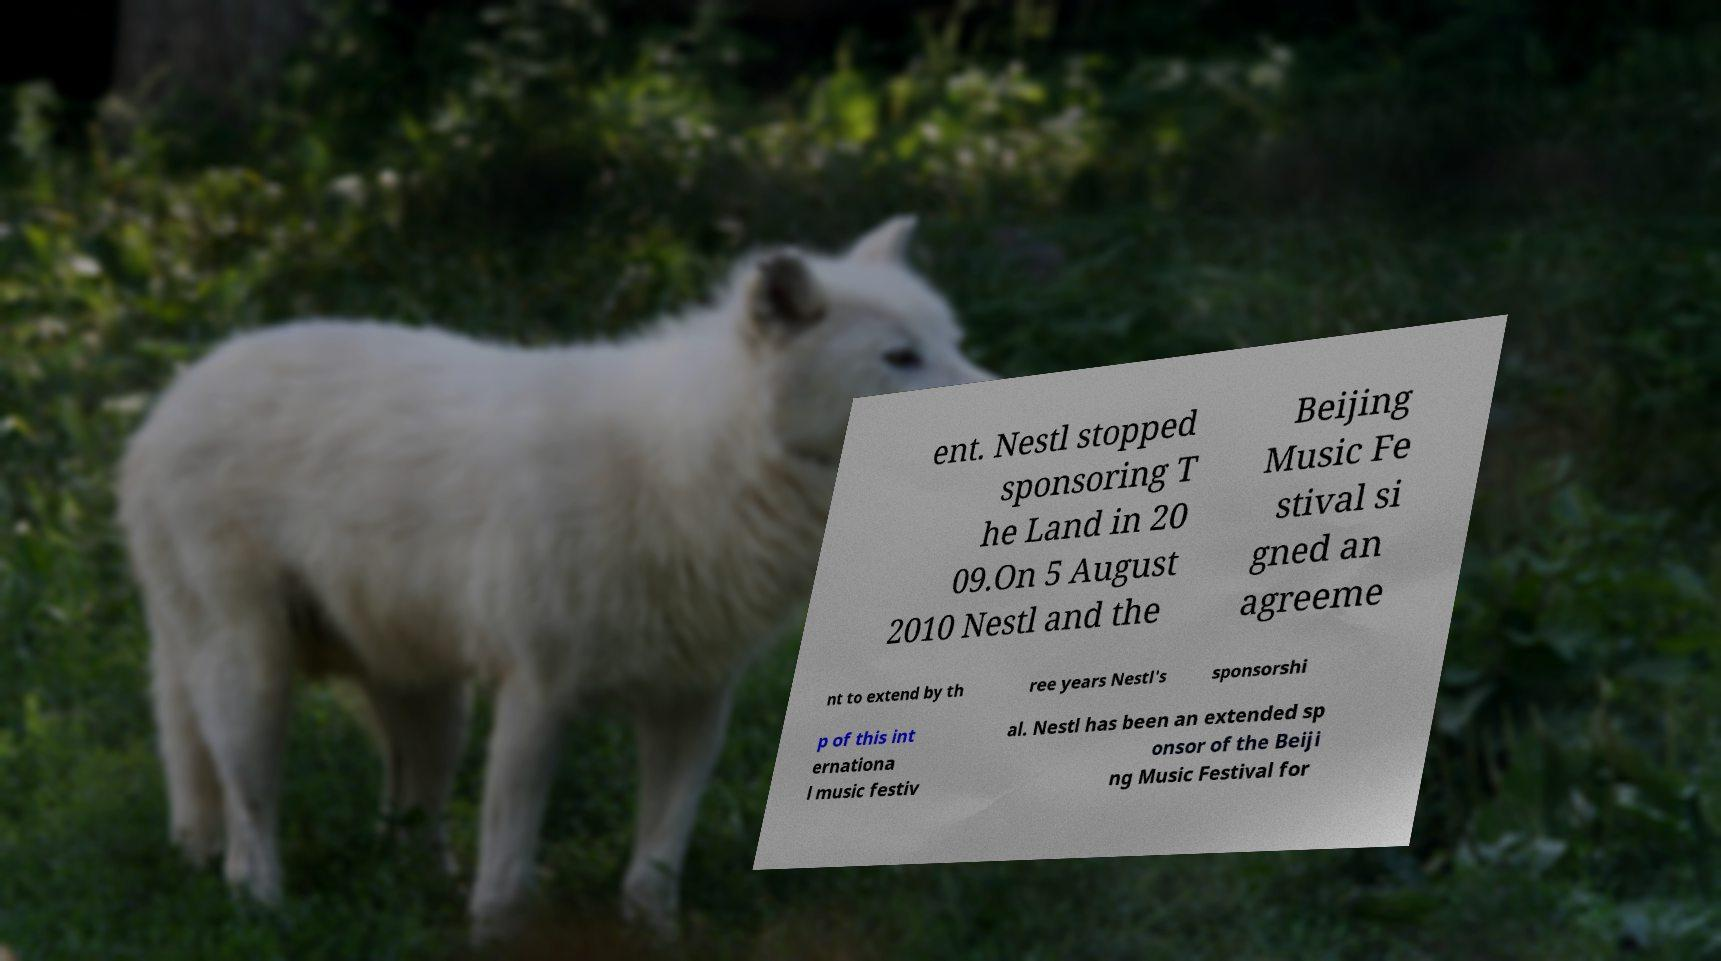Please identify and transcribe the text found in this image. ent. Nestl stopped sponsoring T he Land in 20 09.On 5 August 2010 Nestl and the Beijing Music Fe stival si gned an agreeme nt to extend by th ree years Nestl's sponsorshi p of this int ernationa l music festiv al. Nestl has been an extended sp onsor of the Beiji ng Music Festival for 